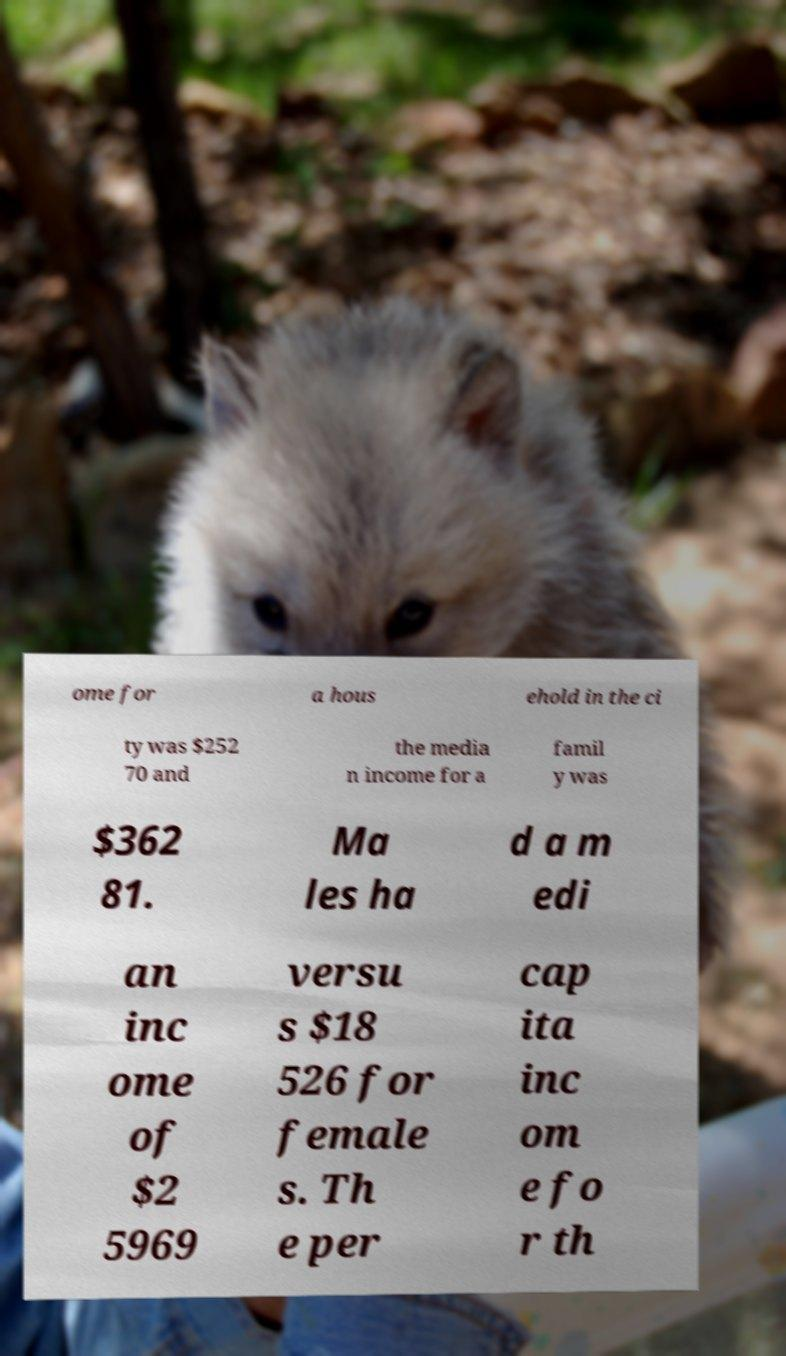I need the written content from this picture converted into text. Can you do that? ome for a hous ehold in the ci ty was $252 70 and the media n income for a famil y was $362 81. Ma les ha d a m edi an inc ome of $2 5969 versu s $18 526 for female s. Th e per cap ita inc om e fo r th 